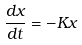<formula> <loc_0><loc_0><loc_500><loc_500>\frac { d x } { d t } = - K x</formula> 